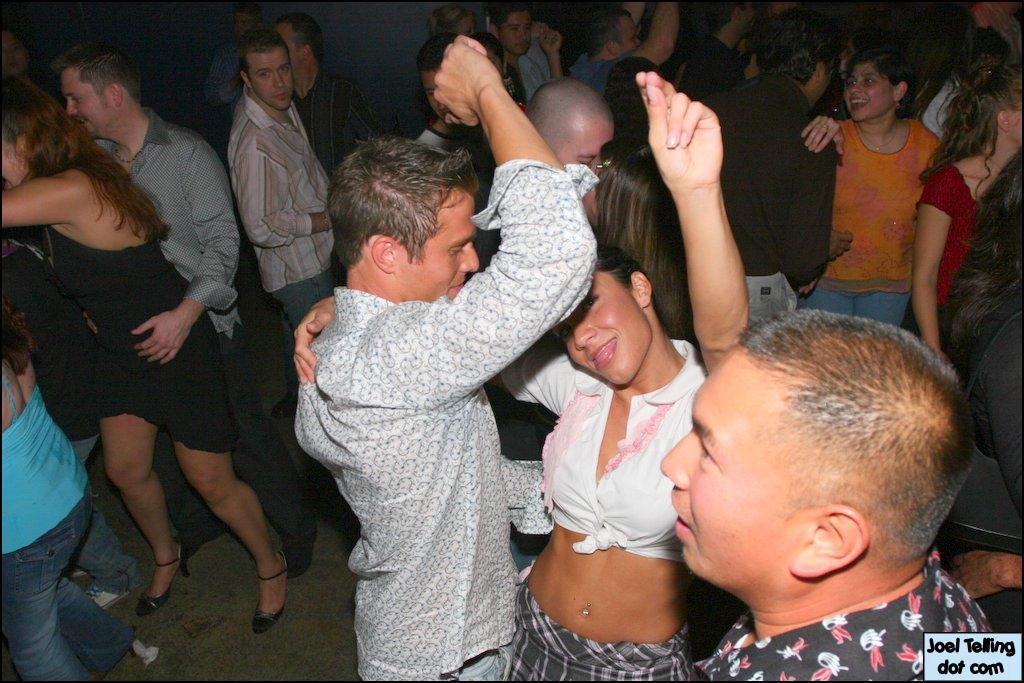What is happening in the image involving the people? Some of the people are dancing, while others are standing. Can you describe the actions of the people in the image? The people are either dancing or standing. What is written or displayed at the bottom of the image? There is text at the bottom of the image. Are the people's friends and pets present in the image? The provided facts do not mention friends or pets, so we cannot determine their presence in the image. 